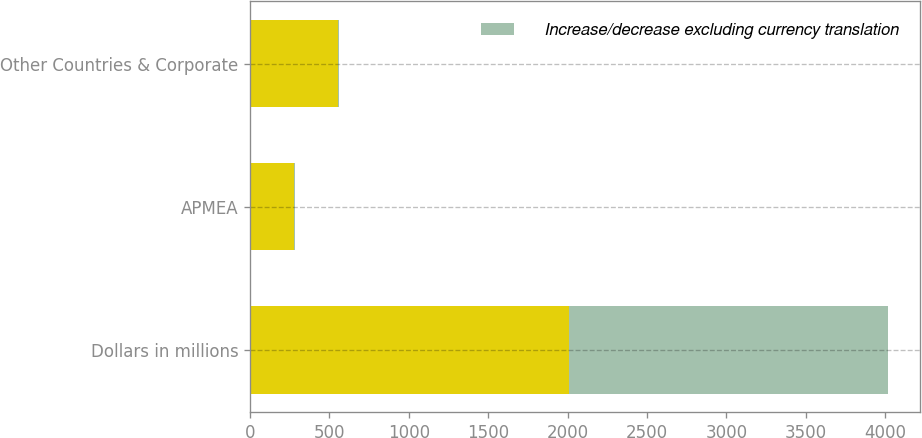Convert chart. <chart><loc_0><loc_0><loc_500><loc_500><stacked_bar_chart><ecel><fcel>Dollars in millions<fcel>APMEA<fcel>Other Countries & Corporate<nl><fcel>nan<fcel>2009<fcel>276<fcel>552<nl><fcel>Increase/decrease excluding currency translation<fcel>2009<fcel>5<fcel>7<nl></chart> 